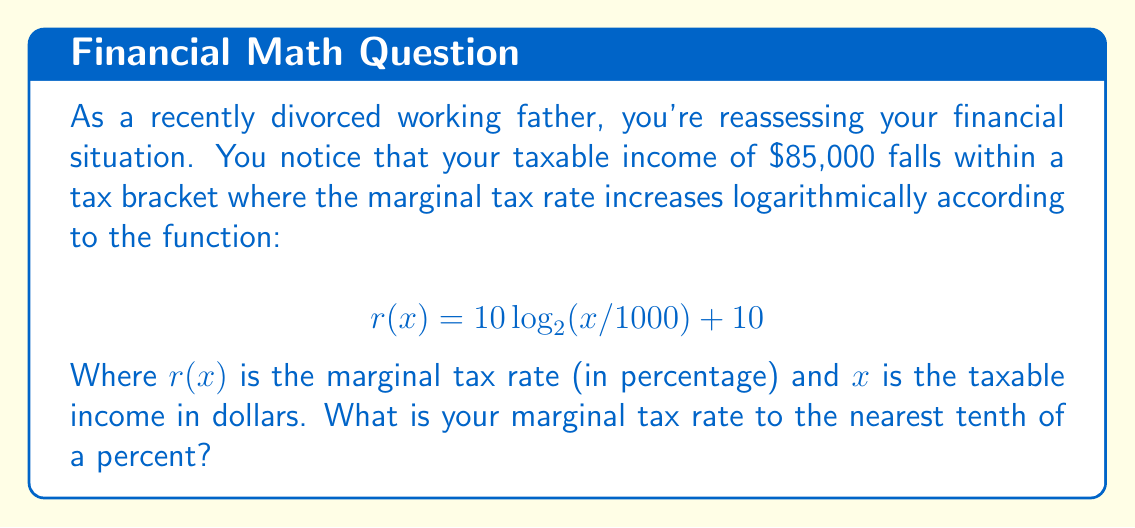Give your solution to this math problem. To solve this problem, we need to follow these steps:

1. Identify the given information:
   - Taxable income (x) = $85,000
   - Tax rate function: $r(x) = 10 \log_{2}(x/1000) + 10$

2. Substitute the taxable income into the function:
   $$r(85000) = 10 \log_{2}(85000/1000) + 10$$

3. Simplify inside the logarithm:
   $$r(85000) = 10 \log_{2}(85) + 10$$

4. Calculate the logarithm:
   $\log_{2}(85) \approx 6.4094$ (using a calculator)

5. Multiply by 10 and add 10:
   $$r(85000) = 10 * 6.4094 + 10 \approx 74.094$$

6. Round to the nearest tenth:
   74.1%

This calculation shows that for your income level, the marginal tax rate is approximately 74.1%.
Answer: 74.1% 